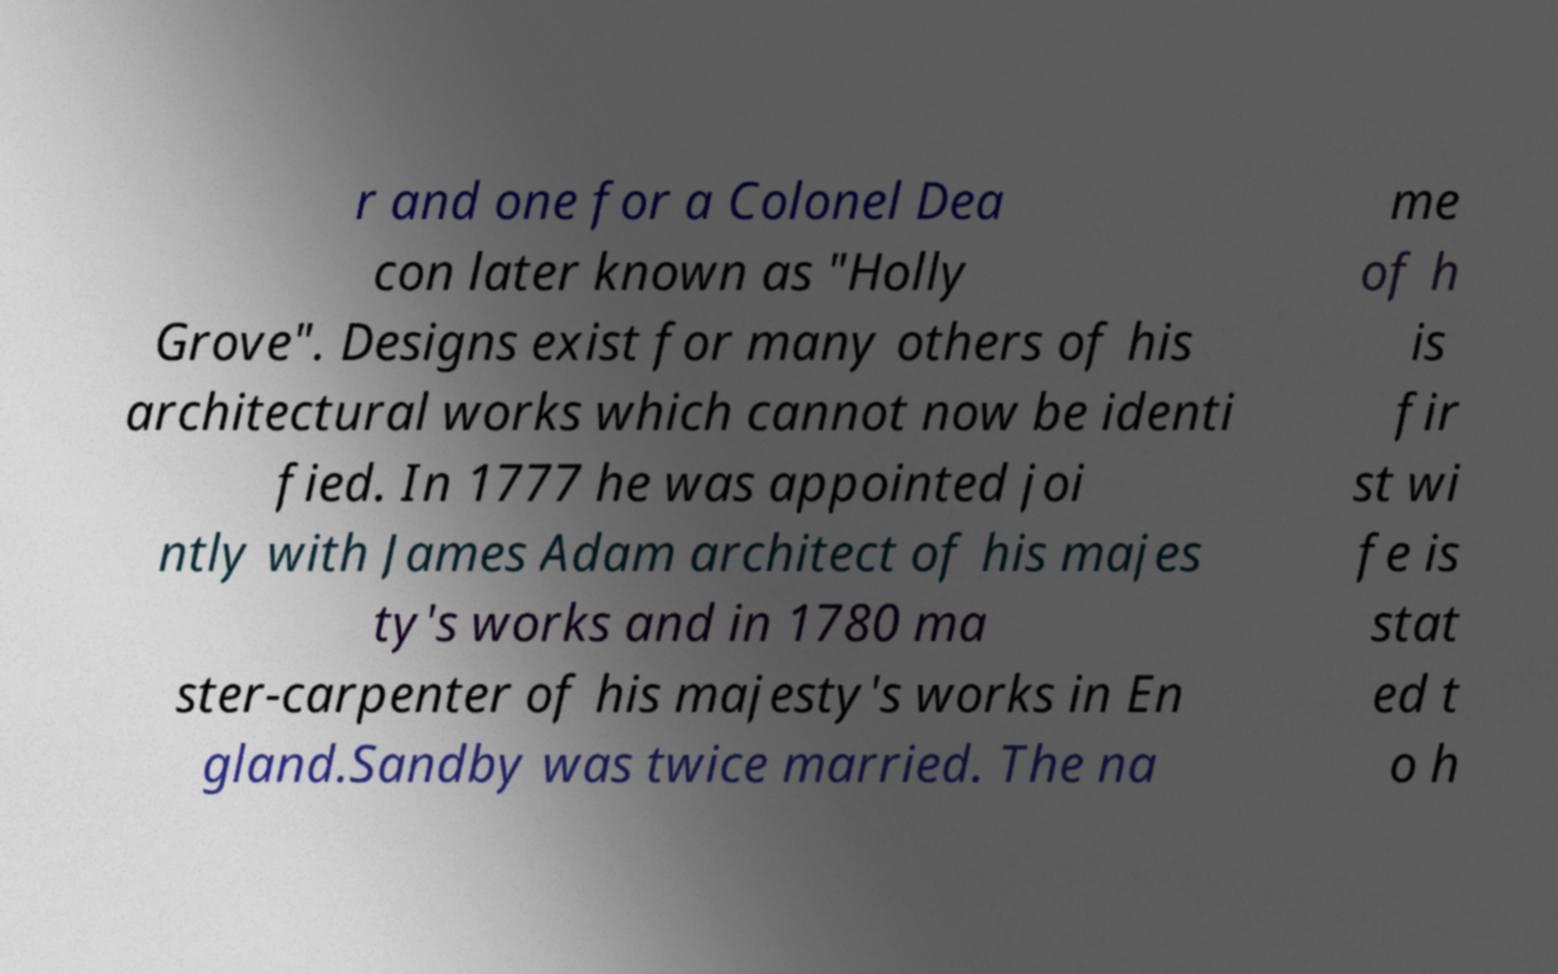Could you extract and type out the text from this image? r and one for a Colonel Dea con later known as "Holly Grove". Designs exist for many others of his architectural works which cannot now be identi fied. In 1777 he was appointed joi ntly with James Adam architect of his majes ty's works and in 1780 ma ster-carpenter of his majesty's works in En gland.Sandby was twice married. The na me of h is fir st wi fe is stat ed t o h 